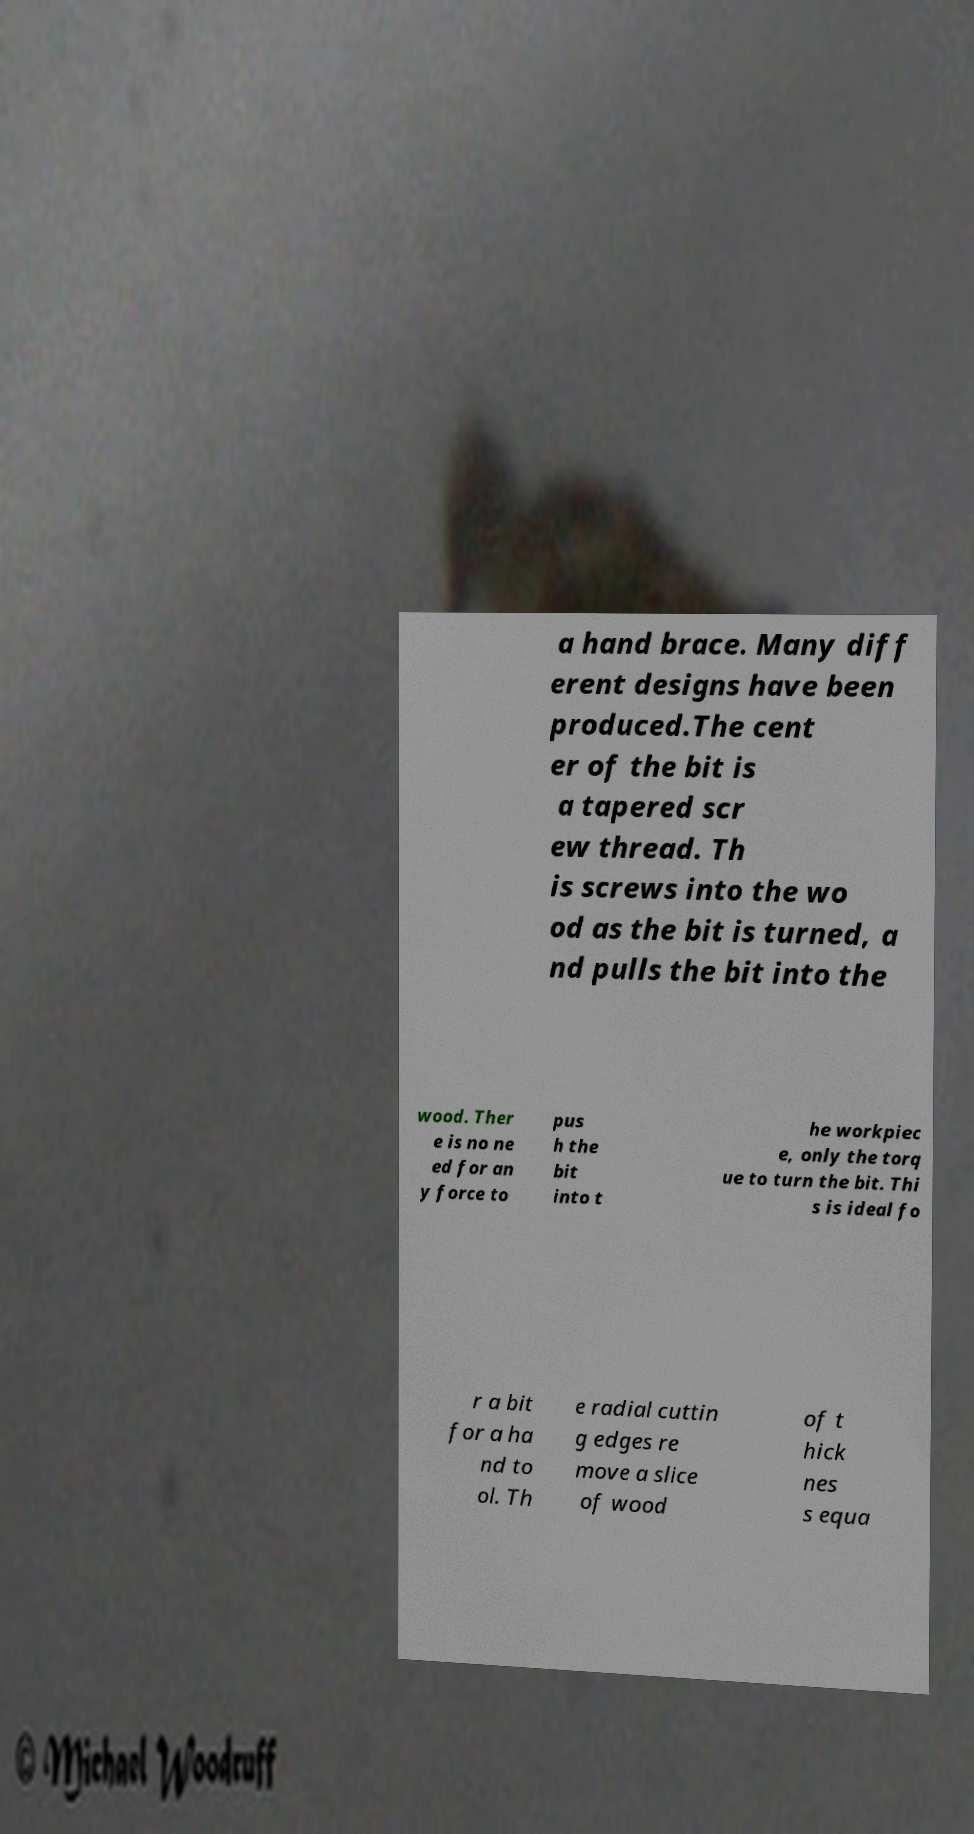What messages or text are displayed in this image? I need them in a readable, typed format. a hand brace. Many diff erent designs have been produced.The cent er of the bit is a tapered scr ew thread. Th is screws into the wo od as the bit is turned, a nd pulls the bit into the wood. Ther e is no ne ed for an y force to pus h the bit into t he workpiec e, only the torq ue to turn the bit. Thi s is ideal fo r a bit for a ha nd to ol. Th e radial cuttin g edges re move a slice of wood of t hick nes s equa 